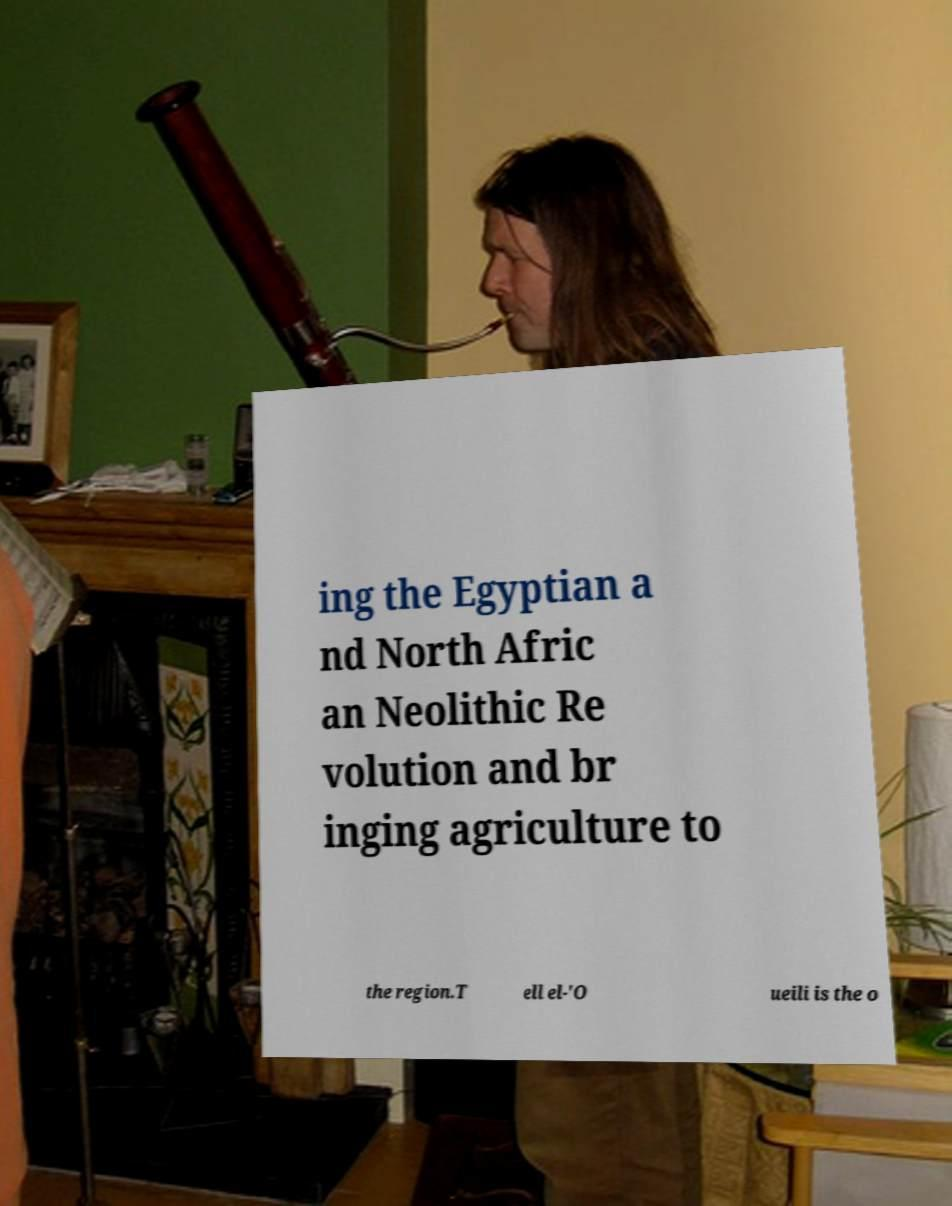Can you read and provide the text displayed in the image?This photo seems to have some interesting text. Can you extract and type it out for me? ing the Egyptian a nd North Afric an Neolithic Re volution and br inging agriculture to the region.T ell el-'O ueili is the o 